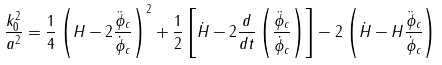Convert formula to latex. <formula><loc_0><loc_0><loc_500><loc_500>\frac { k ^ { 2 } _ { 0 } } { a ^ { 2 } } = \frac { 1 } { 4 } \left ( H - 2 \frac { \ddot { \phi } _ { c } } { \dot { \phi } _ { c } } \right ) ^ { 2 } + \frac { 1 } { 2 } \left [ \dot { H } - 2 \frac { d } { d t } \left ( \frac { \ddot { \phi } _ { c } } { \dot { \phi } _ { c } } \right ) \right ] - 2 \left ( \dot { H } - H \frac { \ddot { \phi } _ { c } } { \dot { \phi } _ { c } } \right )</formula> 